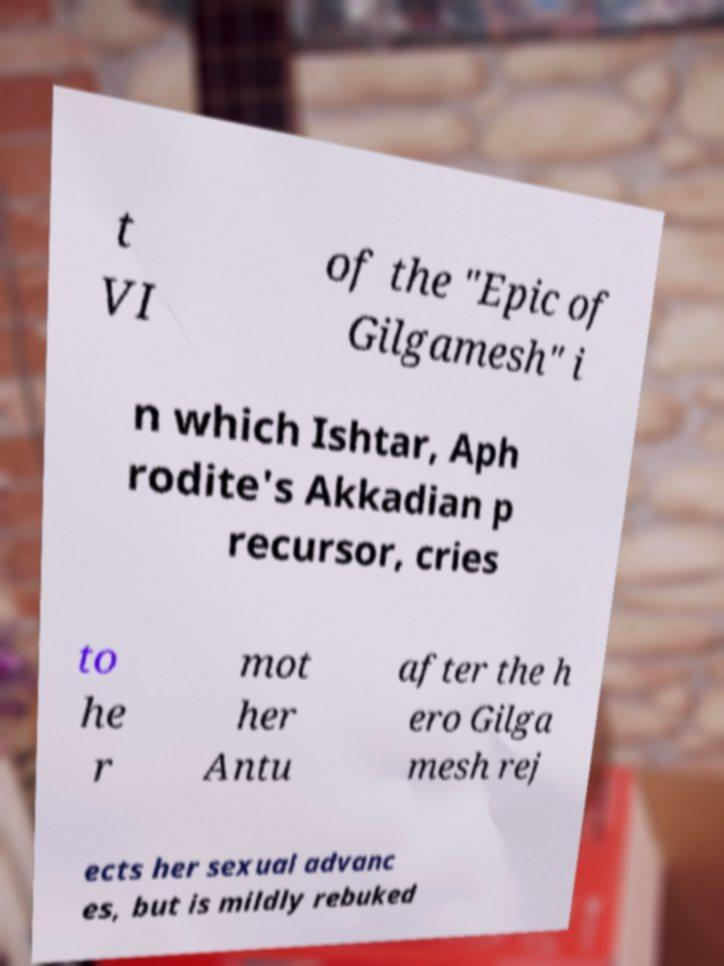There's text embedded in this image that I need extracted. Can you transcribe it verbatim? t VI of the "Epic of Gilgamesh" i n which Ishtar, Aph rodite's Akkadian p recursor, cries to he r mot her Antu after the h ero Gilga mesh rej ects her sexual advanc es, but is mildly rebuked 